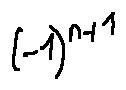<formula> <loc_0><loc_0><loc_500><loc_500>( - 1 ) ^ { n + 1 }</formula> 